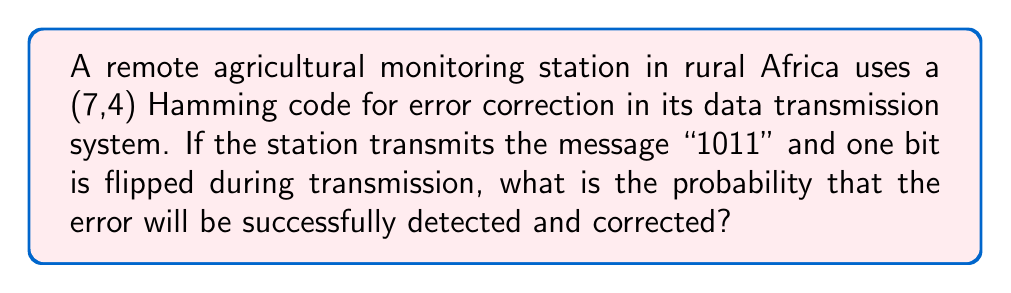Give your solution to this math problem. To solve this problem, we need to understand the properties of the (7,4) Hamming code and analyze its error correction capabilities:

1. The (7,4) Hamming code encodes 4 data bits into 7 bits by adding 3 parity bits.

2. This code can detect and correct all single-bit errors in the 7-bit codeword.

3. The encoding process:
   - Let the data bits be $d_1, d_2, d_3, d_4$
   - The parity bits are calculated as:
     $p_1 = d_1 \oplus d_2 \oplus d_4$
     $p_2 = d_1 \oplus d_3 \oplus d_4$
     $p_3 = d_2 \oplus d_3 \oplus d_4$
   - The transmitted codeword is $[d_1, d_2, d_3, d_4, p_1, p_2, p_3]$

4. For the given message "1011":
   $d_1 = 1, d_2 = 0, d_3 = 1, d_4 = 1$
   $p_1 = 1 \oplus 0 \oplus 1 = 0$
   $p_2 = 1 \oplus 1 \oplus 1 = 1$
   $p_3 = 0 \oplus 1 \oplus 1 = 0$
   
   The transmitted codeword is $[1, 0, 1, 1, 0, 1, 0]$

5. The probability of successful detection and correction:
   - The code can correct any single-bit error in the 7-bit codeword.
   - The question states that one bit is flipped during transmission.
   - Therefore, the probability of successful detection and correction is 1 (or 100%).

This high reliability is crucial for agricultural monitoring stations in remote African locations, where data integrity is essential for accurate analysis and decision-making in agricultural development projects.
Answer: The probability that the error will be successfully detected and corrected is 1 (or 100%). 